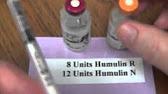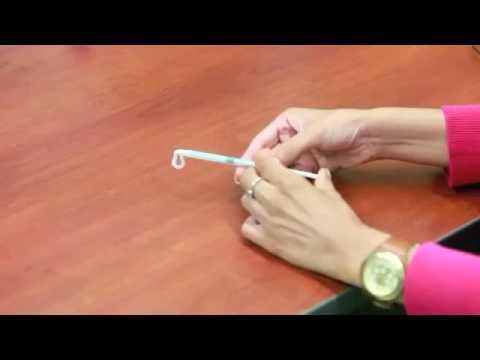The first image is the image on the left, the second image is the image on the right. Evaluate the accuracy of this statement regarding the images: "There are four bare hands working with needles.". Is it true? Answer yes or no. No. The first image is the image on the left, the second image is the image on the right. Considering the images on both sides, is "At least one needle attached to a syringe is visible." valid? Answer yes or no. No. 